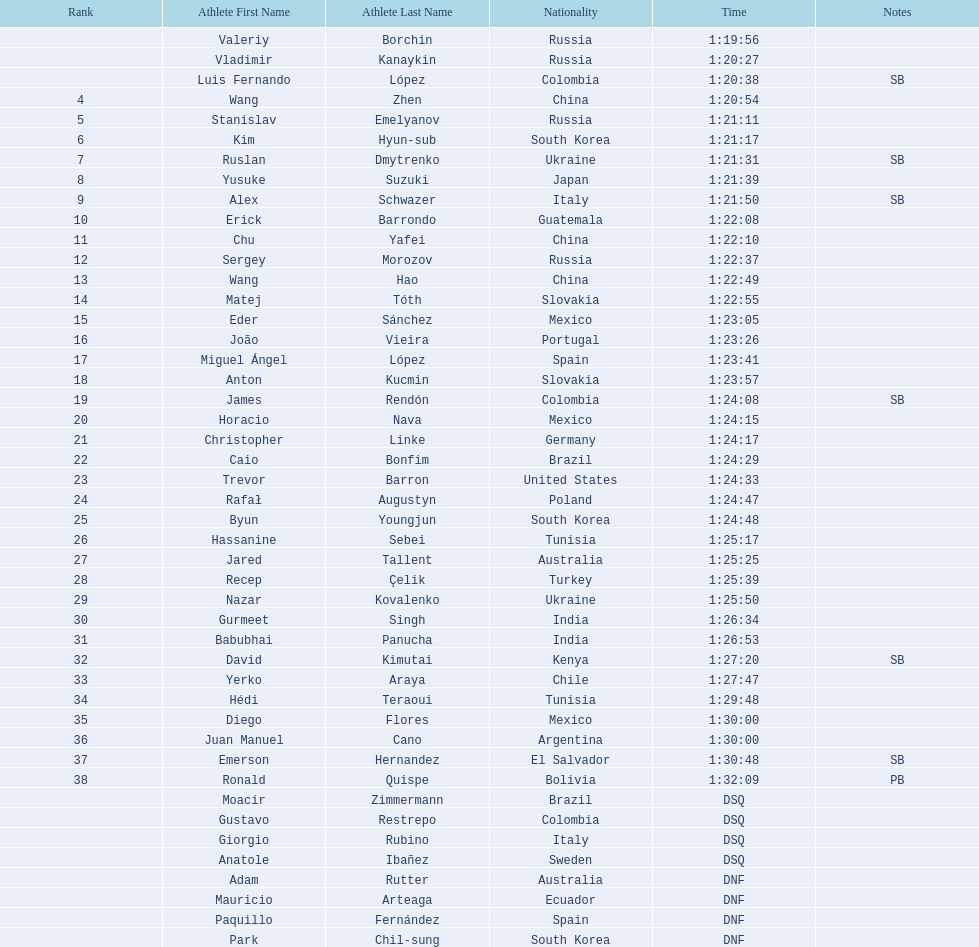Which chinese athlete had the fastest time? Wang Zhen. 